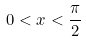Convert formula to latex. <formula><loc_0><loc_0><loc_500><loc_500>0 < x < \frac { \pi } { 2 }</formula> 